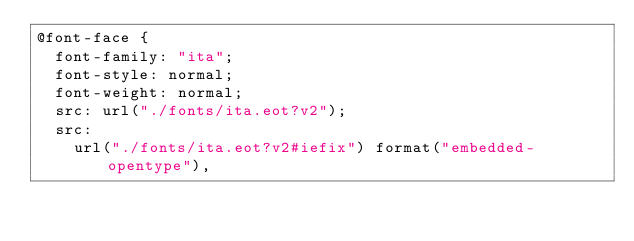Convert code to text. <code><loc_0><loc_0><loc_500><loc_500><_CSS_>@font-face {
  font-family: "ita";
  font-style: normal;
  font-weight: normal;
  src: url("./fonts/ita.eot?v2");
  src:
    url("./fonts/ita.eot?v2#iefix") format("embedded-opentype"),</code> 